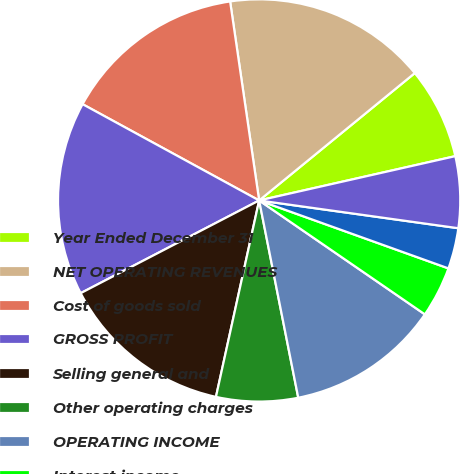<chart> <loc_0><loc_0><loc_500><loc_500><pie_chart><fcel>Year Ended December 31<fcel>NET OPERATING REVENUES<fcel>Cost of goods sold<fcel>GROSS PROFIT<fcel>Selling general and<fcel>Other operating charges<fcel>OPERATING INCOME<fcel>Interest income<fcel>Interest e xpense<fcel>Equity income (loss) - net<nl><fcel>7.38%<fcel>16.39%<fcel>14.75%<fcel>15.57%<fcel>13.93%<fcel>6.56%<fcel>12.3%<fcel>4.1%<fcel>3.28%<fcel>5.74%<nl></chart> 